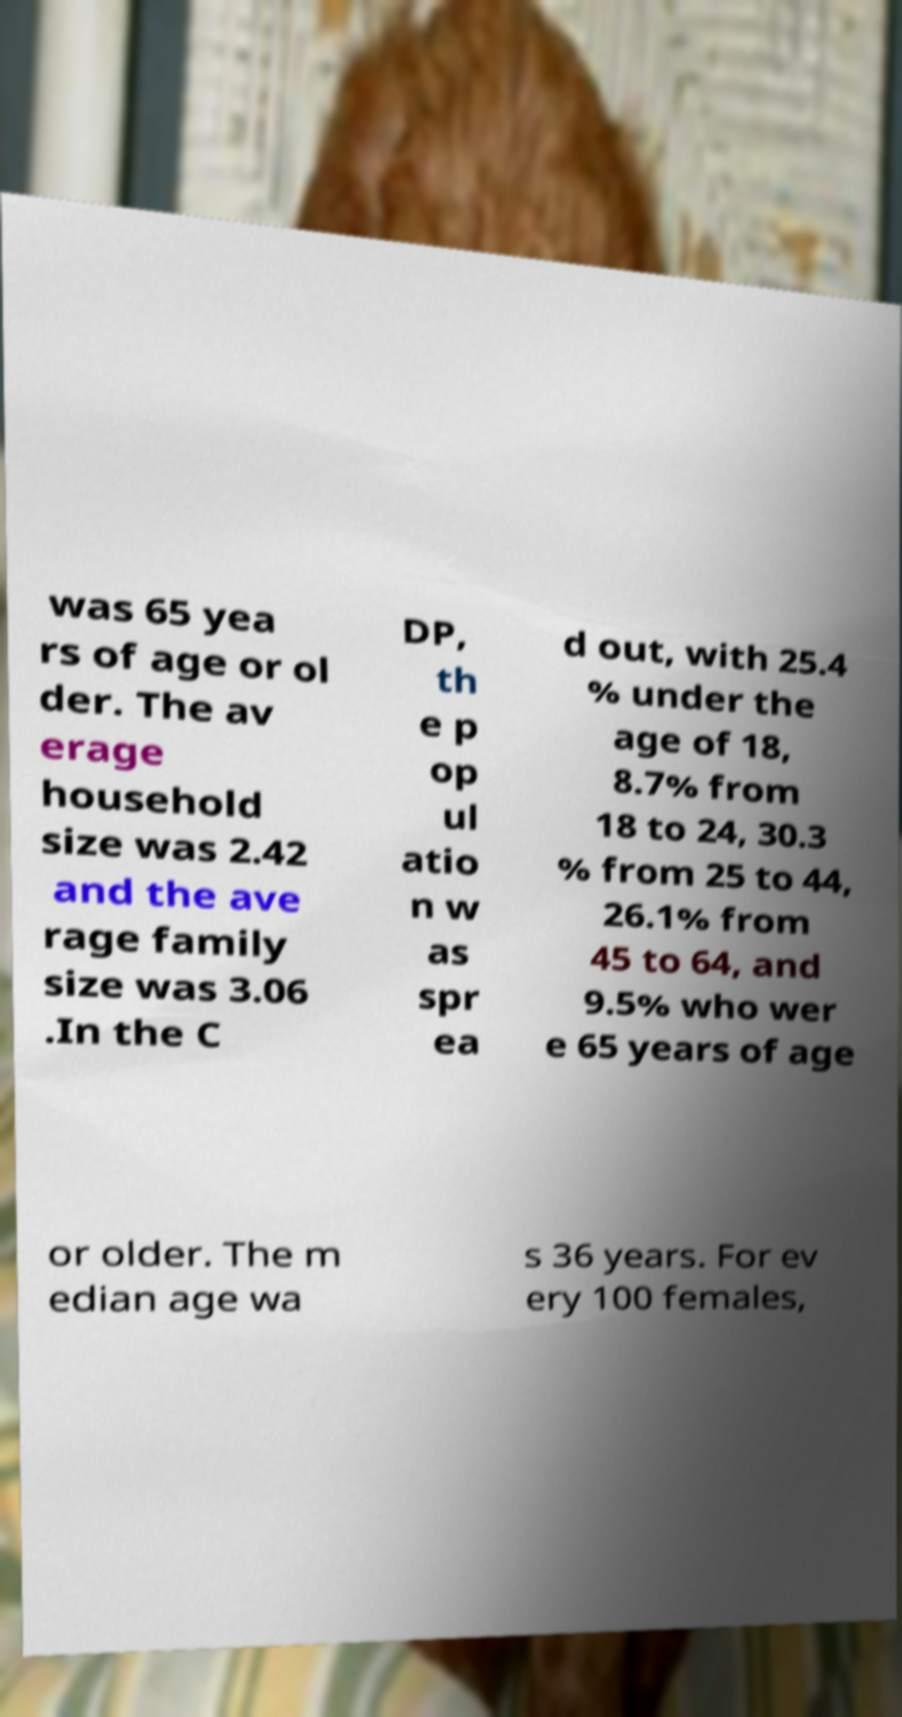There's text embedded in this image that I need extracted. Can you transcribe it verbatim? was 65 yea rs of age or ol der. The av erage household size was 2.42 and the ave rage family size was 3.06 .In the C DP, th e p op ul atio n w as spr ea d out, with 25.4 % under the age of 18, 8.7% from 18 to 24, 30.3 % from 25 to 44, 26.1% from 45 to 64, and 9.5% who wer e 65 years of age or older. The m edian age wa s 36 years. For ev ery 100 females, 